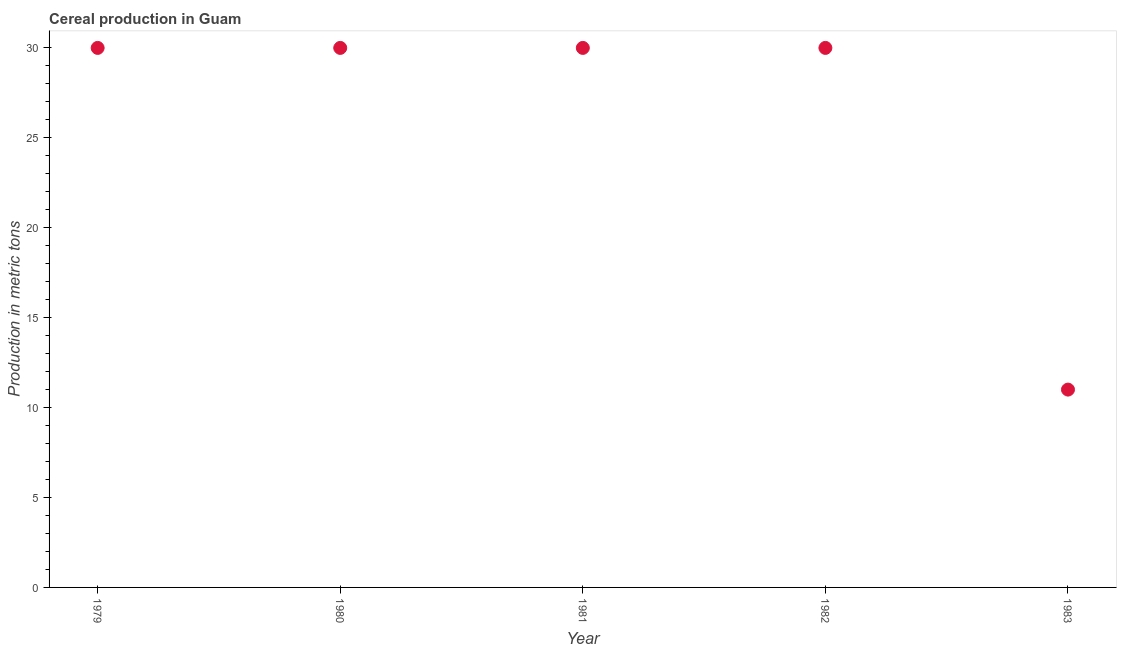What is the cereal production in 1983?
Your answer should be very brief. 11. Across all years, what is the maximum cereal production?
Keep it short and to the point. 30. Across all years, what is the minimum cereal production?
Give a very brief answer. 11. In which year was the cereal production maximum?
Offer a terse response. 1979. In which year was the cereal production minimum?
Provide a succinct answer. 1983. What is the sum of the cereal production?
Give a very brief answer. 131. What is the difference between the cereal production in 1981 and 1983?
Give a very brief answer. 19. What is the average cereal production per year?
Offer a very short reply. 26.2. In how many years, is the cereal production greater than 22 metric tons?
Your answer should be compact. 4. What is the ratio of the cereal production in 1979 to that in 1983?
Your answer should be compact. 2.73. Is the cereal production in 1981 less than that in 1983?
Your answer should be compact. No. What is the difference between the highest and the second highest cereal production?
Keep it short and to the point. 0. What is the difference between the highest and the lowest cereal production?
Provide a succinct answer. 19. In how many years, is the cereal production greater than the average cereal production taken over all years?
Your answer should be very brief. 4. How many dotlines are there?
Offer a terse response. 1. What is the difference between two consecutive major ticks on the Y-axis?
Your response must be concise. 5. Are the values on the major ticks of Y-axis written in scientific E-notation?
Your response must be concise. No. Does the graph contain any zero values?
Give a very brief answer. No. What is the title of the graph?
Offer a terse response. Cereal production in Guam. What is the label or title of the Y-axis?
Make the answer very short. Production in metric tons. What is the Production in metric tons in 1979?
Provide a short and direct response. 30. What is the difference between the Production in metric tons in 1979 and 1983?
Your answer should be very brief. 19. What is the difference between the Production in metric tons in 1980 and 1981?
Give a very brief answer. 0. What is the difference between the Production in metric tons in 1980 and 1982?
Your response must be concise. 0. What is the difference between the Production in metric tons in 1981 and 1982?
Offer a terse response. 0. What is the difference between the Production in metric tons in 1982 and 1983?
Keep it short and to the point. 19. What is the ratio of the Production in metric tons in 1979 to that in 1980?
Offer a very short reply. 1. What is the ratio of the Production in metric tons in 1979 to that in 1982?
Keep it short and to the point. 1. What is the ratio of the Production in metric tons in 1979 to that in 1983?
Offer a terse response. 2.73. What is the ratio of the Production in metric tons in 1980 to that in 1983?
Your answer should be very brief. 2.73. What is the ratio of the Production in metric tons in 1981 to that in 1982?
Offer a terse response. 1. What is the ratio of the Production in metric tons in 1981 to that in 1983?
Provide a succinct answer. 2.73. What is the ratio of the Production in metric tons in 1982 to that in 1983?
Your answer should be compact. 2.73. 